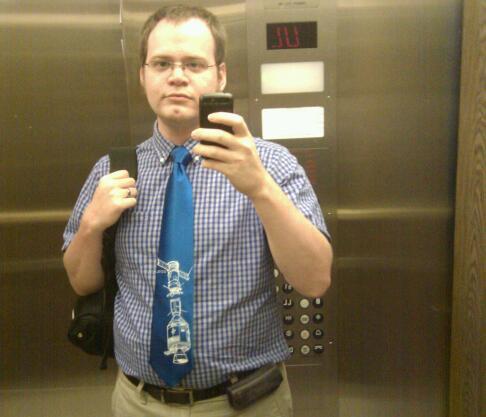How many orange buttons on the toilet?
Give a very brief answer. 0. 